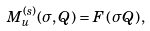Convert formula to latex. <formula><loc_0><loc_0><loc_500><loc_500>M _ { u } ^ { ( s ) } ( \sigma , Q ) = F \left ( \sigma Q \right ) ,</formula> 